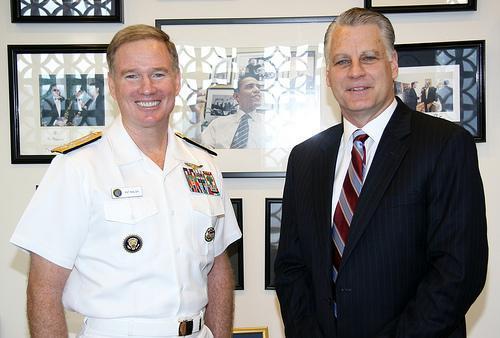How many uniformed men are there?
Give a very brief answer. 1. How many of the frames have white mating around their pictures?
Give a very brief answer. 3. 